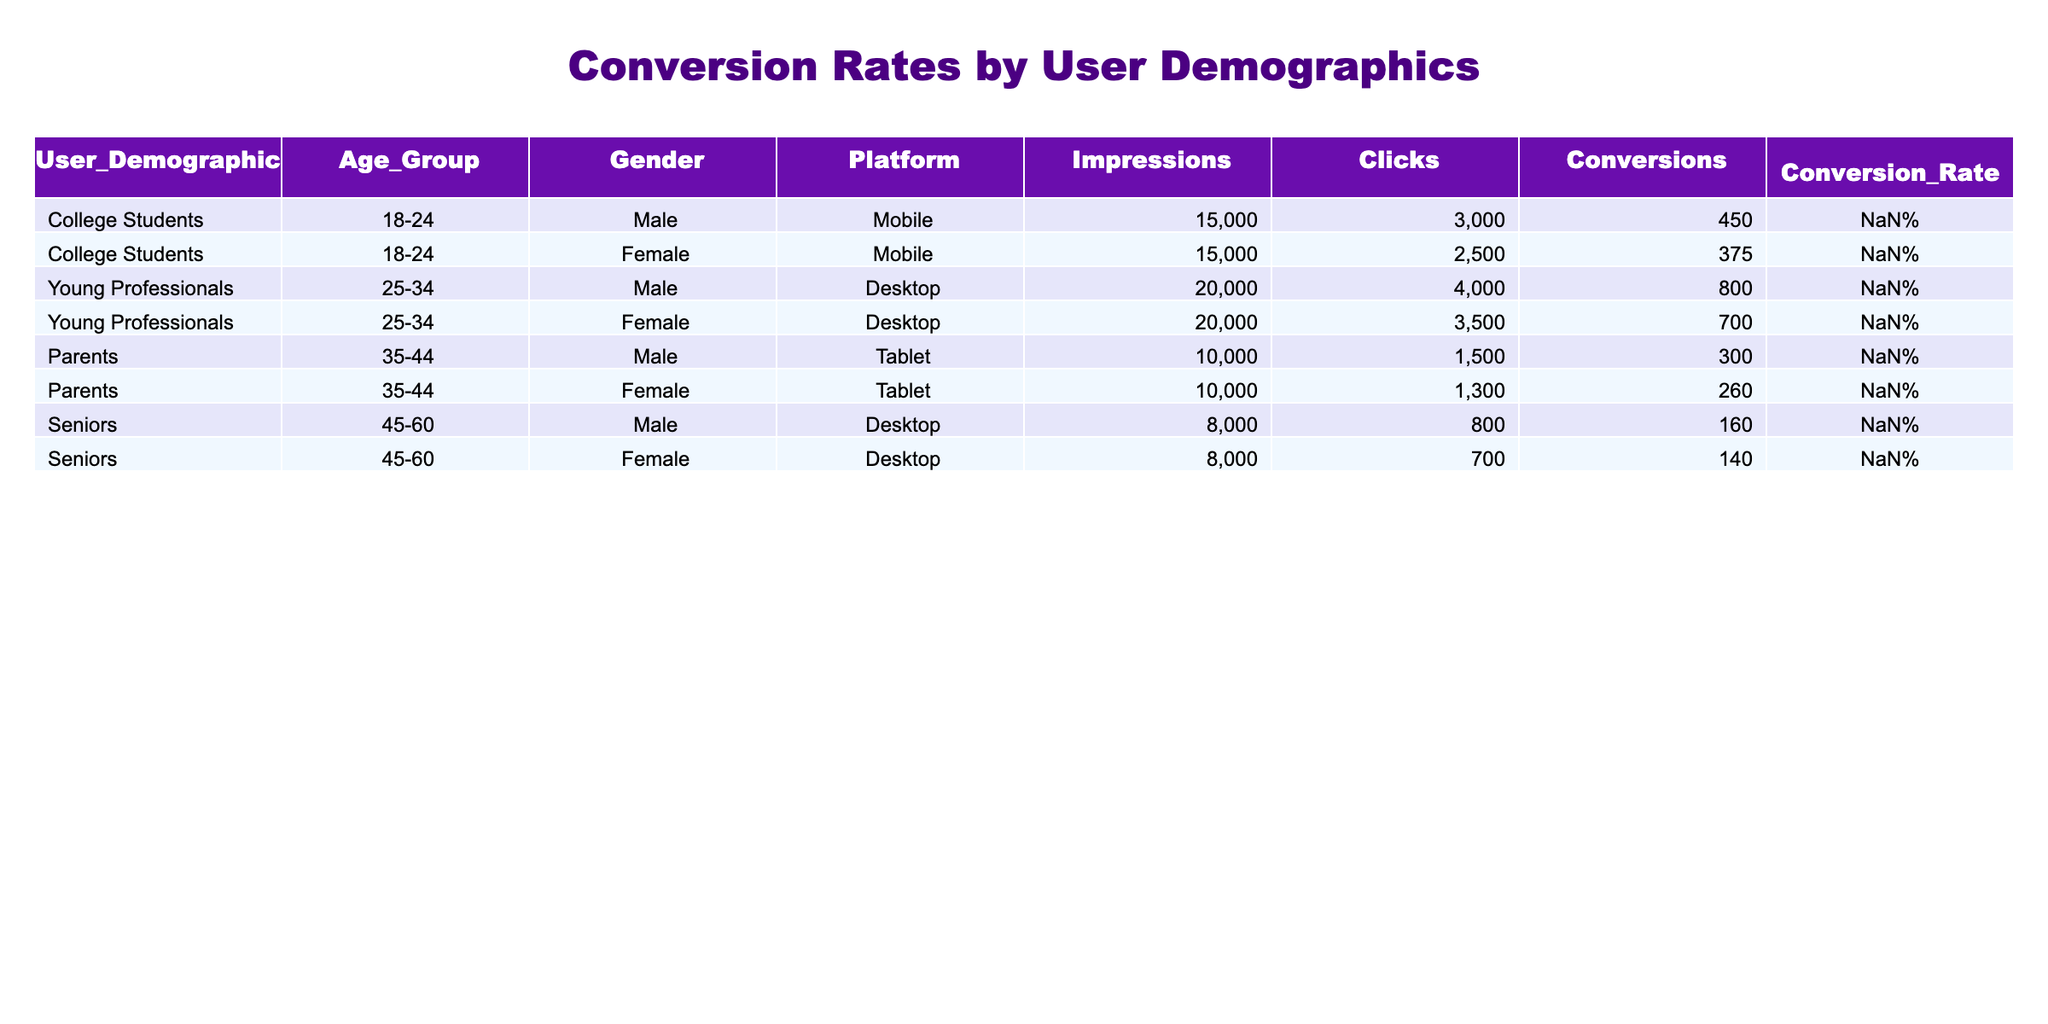What is the conversion rate for College Students aged 18-24, Female, on the Mobile platform? The table shows that the entry for College Students, 18-24, Female on Mobile has a conversion rate of 2.50%.
Answer: 2.50% Which age group has the highest conversion rate? The conversion rates for the age groups are as follows: 18-24 (3.00% for Male, 2.50% for Female), 25-34 (4.00% for Male, 3.50% for Female), 35-44 (3.00% for Male, 2.60% for Female), and 45-60 (2.00% for Male, 1.75% for Female). The highest conversion rate of 4.00% is found in the 25-34 age group for Young Professionals, Male on Desktop.
Answer: 25-34 What is the total number of conversions for the "Parents" demographic? The conversions for Parents, Male is 300 and for Parents, Female is 260. Adding these gives 300 + 260 = 560.
Answer: 560 Do Young Professionals on Desktop have a higher conversion rate than College Students on Mobile? The conversion rates are 4.00% for Young Professionals, Male and 3.50% for Young Professionals, Female on Desktop compared to 3.00% (Male) and 2.50% (Female) for College Students on Mobile. Both rates for Young Professionals are higher, confirming yes.
Answer: Yes What is the average conversion rate across all demographics? To find the average conversion rate, add all conversion rates: (3.00% + 2.50% + 4.00% + 3.50% + 3.00% + 2.60% + 2.00% + 1.75%) = 18.35%, then divide by 8 demographics which equals approximately 2.29%.
Answer: 2.29% 